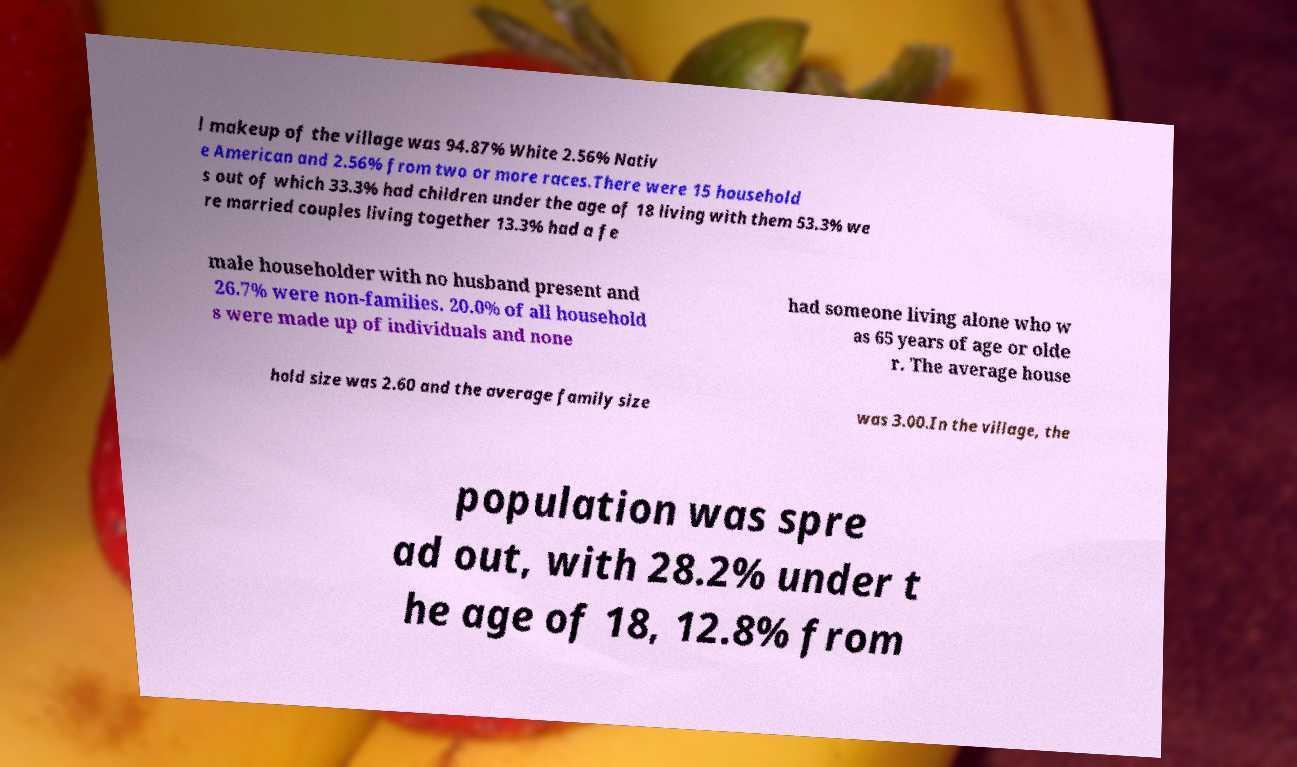I need the written content from this picture converted into text. Can you do that? l makeup of the village was 94.87% White 2.56% Nativ e American and 2.56% from two or more races.There were 15 household s out of which 33.3% had children under the age of 18 living with them 53.3% we re married couples living together 13.3% had a fe male householder with no husband present and 26.7% were non-families. 20.0% of all household s were made up of individuals and none had someone living alone who w as 65 years of age or olde r. The average house hold size was 2.60 and the average family size was 3.00.In the village, the population was spre ad out, with 28.2% under t he age of 18, 12.8% from 